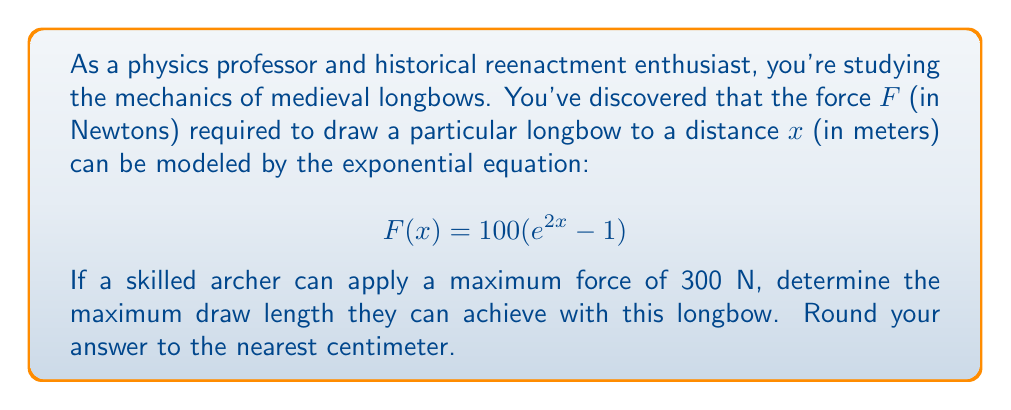Could you help me with this problem? To solve this problem, we'll follow these steps:

1) We start with the given equation:
   $$F(x) = 100(e^{2x} - 1)$$

2) We know the maximum force the archer can apply is 300 N, so we set F(x) = 300:
   $$300 = 100(e^{2x} - 1)$$

3) Divide both sides by 100:
   $$3 = e^{2x} - 1$$

4) Add 1 to both sides:
   $$4 = e^{2x}$$

5) Take the natural logarithm of both sides:
   $$\ln(4) = \ln(e^{2x})$$

6) Simplify the right side using the logarithm property $\ln(e^x) = x$:
   $$\ln(4) = 2x$$

7) Divide both sides by 2:
   $$\frac{\ln(4)}{2} = x$$

8) Calculate the value:
   $$x = \frac{\ln(4)}{2} \approx 0.6931$$

9) Convert to centimeters by multiplying by 100 and rounding to the nearest whole number:
   $$0.6931 \times 100 \approx 69.31 \approx 69 \text{ cm}$$

Therefore, the maximum draw length the archer can achieve is approximately 69 cm.
Answer: 69 cm 